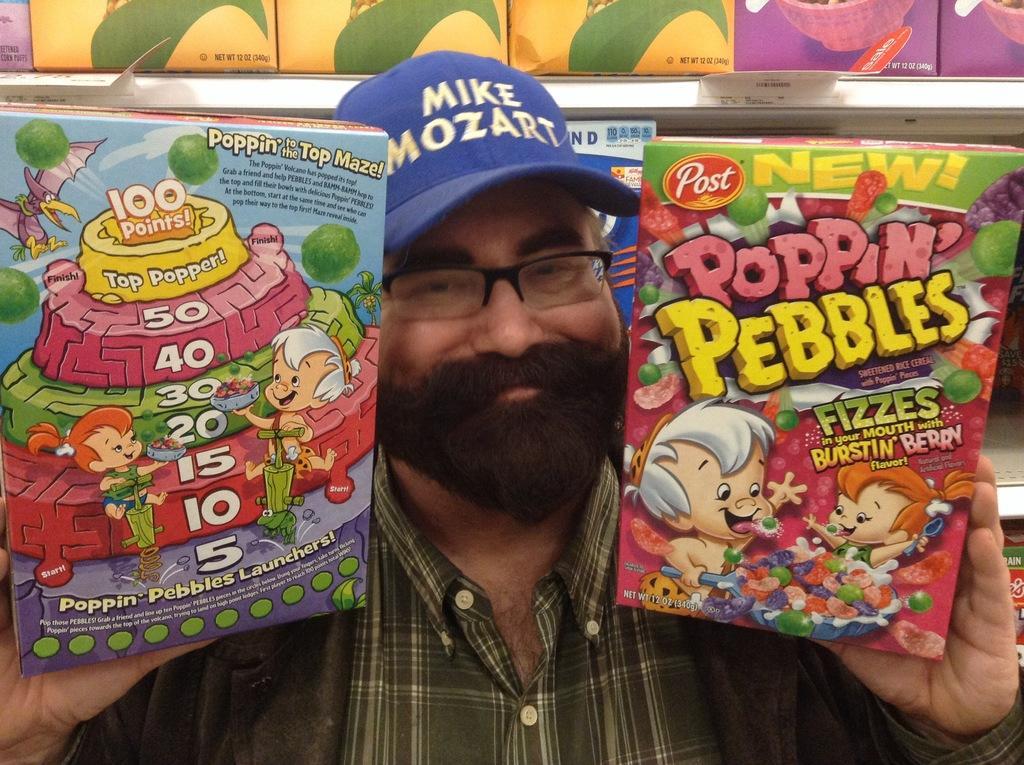Could you give a brief overview of what you see in this image? In this picture there is a man who is wearing cap, spectacle, shirt and jacket. He is holding two boxes. Behind him I can see many boxes which are kept on the racks. 